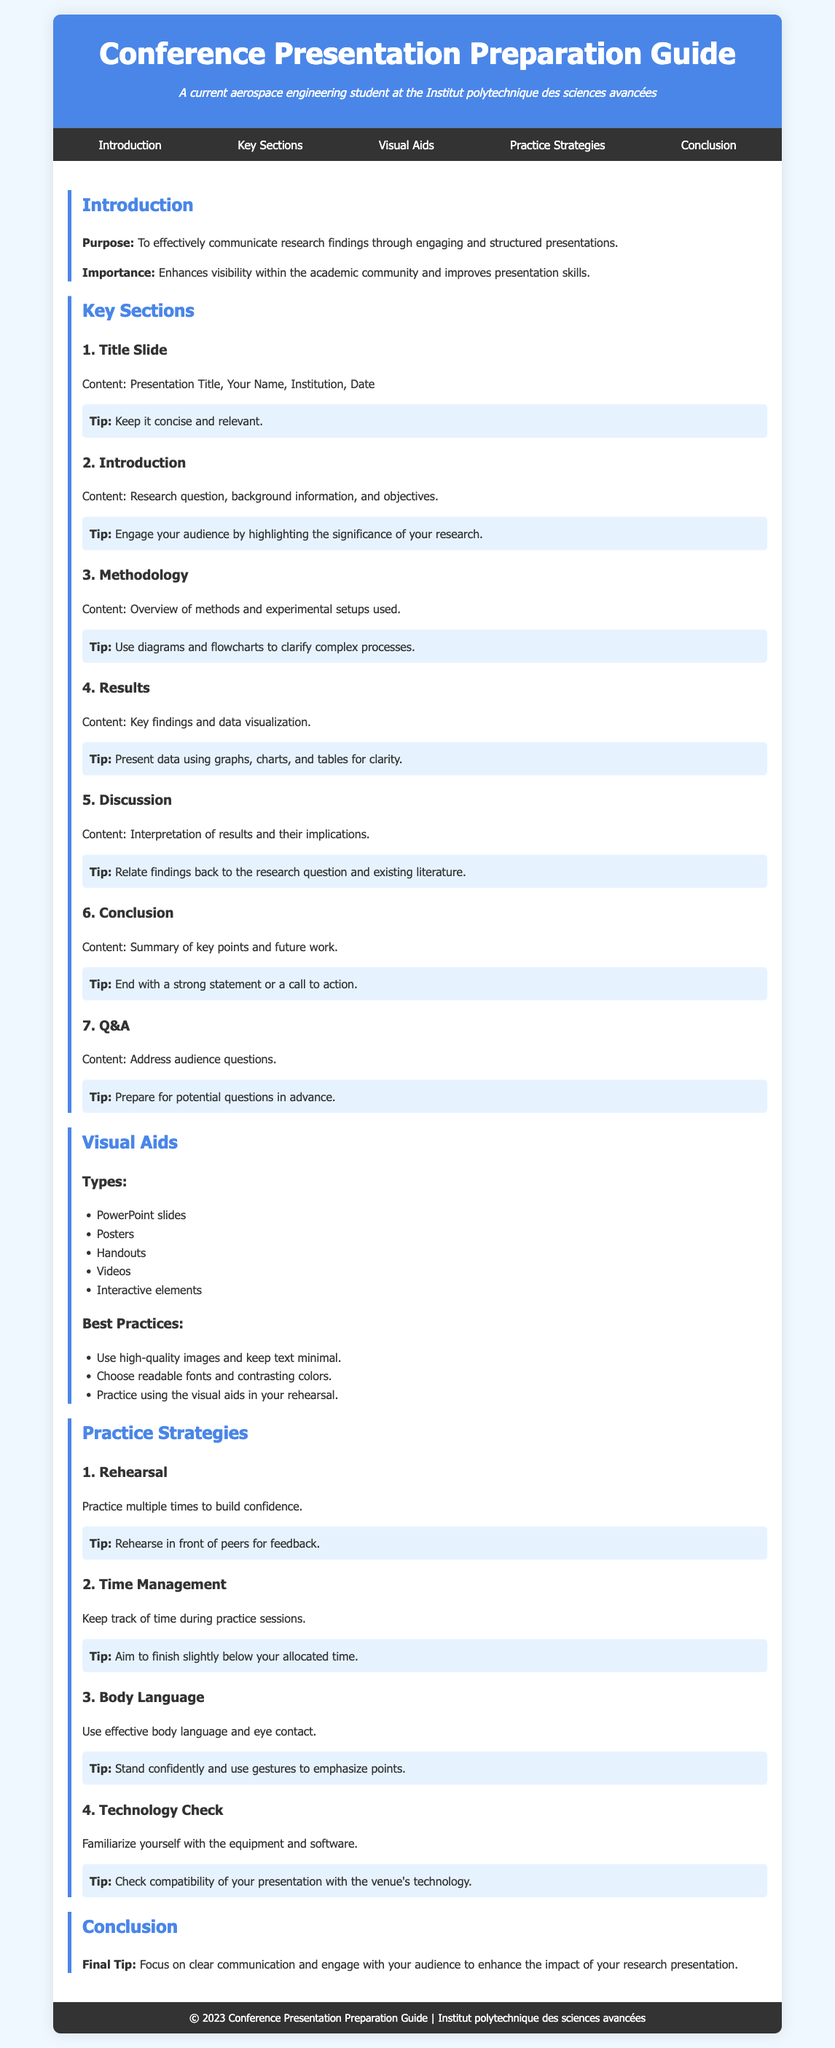What is the title of the guide? The title of the guide is presented in the header of the document.
Answer: Conference Presentation Preparation Guide What is the first key section mentioned? The first key section is listed in the "Key Sections" section of the document.
Answer: Title Slide How many visual aid types are listed? The visual aid types are specified under the "Visual Aids" section in a bulleted list.
Answer: Five What is a recommended practice for rehearsals? The tips for practice strategies include specific recommendations for rehearsal, found in the "Practice Strategies" section.
Answer: Rehearse in front of peers for feedback What should be included in the conclusion section? The final section discusses what should be summarized or highlighted, specifically in the conclusion.
Answer: Summary of key points and future work What color is the header background? The header's background color is described within the document's styling information.
Answer: #4a86e8 Which visual aid best practice emphasizes the use of images? The best practices for visual aids include guidelines that mention the use of images, found in the "Visual Aids" section.
Answer: Use high-quality images and keep text minimal What is the purpose of this guide? The purpose of the guide is explicitly stated in the introduction section of the document.
Answer: To effectively communicate research findings through engaging and structured presentations 